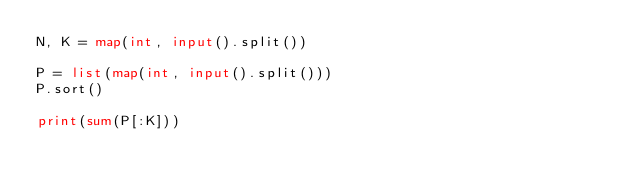<code> <loc_0><loc_0><loc_500><loc_500><_Python_>N, K = map(int, input().split())
 
P = list(map(int, input().split()))
P.sort()
 
print(sum(P[:K]))</code> 